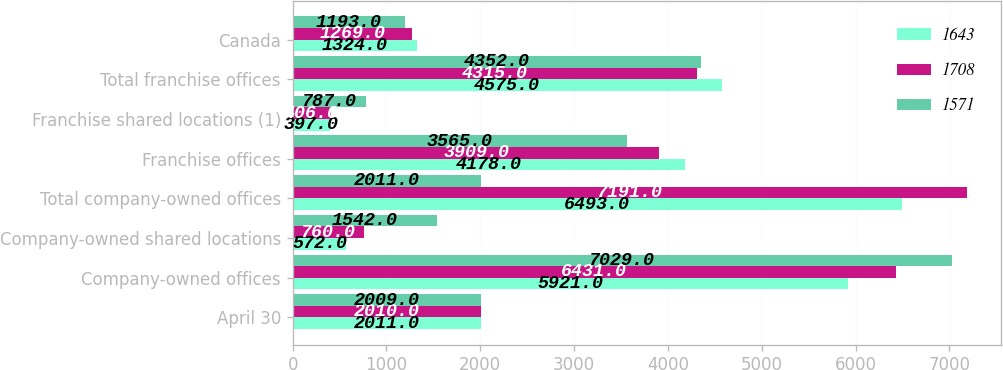Convert chart. <chart><loc_0><loc_0><loc_500><loc_500><stacked_bar_chart><ecel><fcel>April 30<fcel>Company-owned offices<fcel>Company-owned shared locations<fcel>Total company-owned offices<fcel>Franchise offices<fcel>Franchise shared locations (1)<fcel>Total franchise offices<fcel>Canada<nl><fcel>1643<fcel>2011<fcel>5921<fcel>572<fcel>6493<fcel>4178<fcel>397<fcel>4575<fcel>1324<nl><fcel>1708<fcel>2010<fcel>6431<fcel>760<fcel>7191<fcel>3909<fcel>406<fcel>4315<fcel>1269<nl><fcel>1571<fcel>2009<fcel>7029<fcel>1542<fcel>2011<fcel>3565<fcel>787<fcel>4352<fcel>1193<nl></chart> 